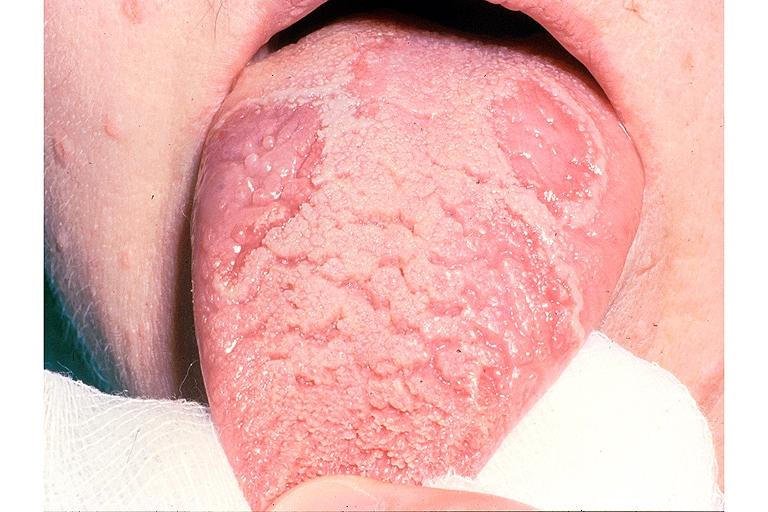does myocardial infarct show benign migratory glossitis and fissured tongue?
Answer the question using a single word or phrase. No 